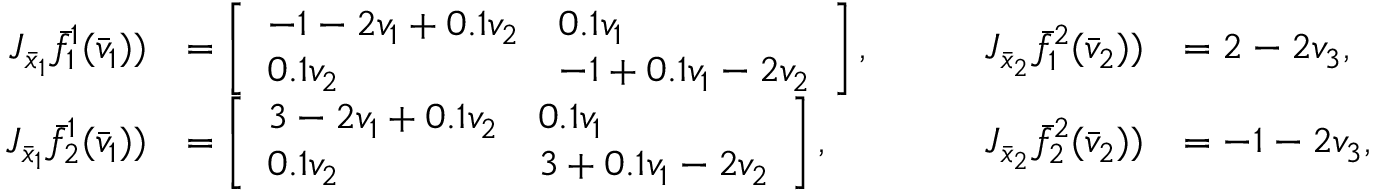Convert formula to latex. <formula><loc_0><loc_0><loc_500><loc_500>\begin{array} { r l r l } { J _ { \bar { x } _ { 1 } } \bar { f } _ { 1 } ^ { 1 } ( \bar { v } _ { 1 } ) ) } & { = \left [ \begin{array} { l l } { - 1 - 2 v _ { 1 } + 0 . 1 v _ { 2 } } & { 0 . 1 v _ { 1 } } \\ { 0 . 1 v _ { 2 } } & { - 1 + 0 . 1 v _ { 1 } - 2 v _ { 2 } } \end{array} \right ] , } & { \quad J _ { \bar { x } _ { 2 } } \bar { f } _ { 1 } ^ { 2 } ( \bar { v } _ { 2 } ) ) } & { = 2 - 2 v _ { 3 } , } \\ { J _ { \bar { x } _ { 1 } } \bar { f } _ { 2 } ^ { 1 } ( \bar { v } _ { 1 } ) ) } & { = \left [ \begin{array} { l l } { 3 - 2 v _ { 1 } + 0 . 1 v _ { 2 } } & { 0 . 1 v _ { 1 } } \\ { 0 . 1 v _ { 2 } } & { 3 + 0 . 1 v _ { 1 } - 2 v _ { 2 } } \end{array} \right ] , } & { \quad J _ { \bar { x } _ { 2 } } \bar { f } _ { 2 } ^ { 2 } ( \bar { v } _ { 2 } ) ) } & { = - 1 - 2 v _ { 3 } , } \end{array}</formula> 